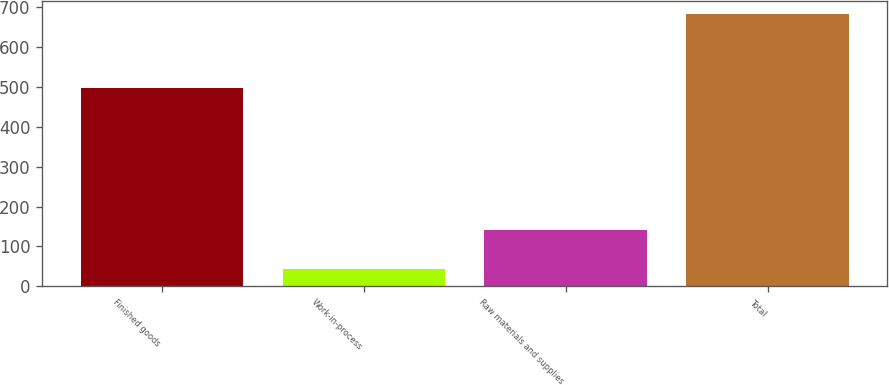Convert chart to OTSL. <chart><loc_0><loc_0><loc_500><loc_500><bar_chart><fcel>Finished goods<fcel>Work-in-process<fcel>Raw materials and supplies<fcel>Total<nl><fcel>498<fcel>43<fcel>141<fcel>682<nl></chart> 